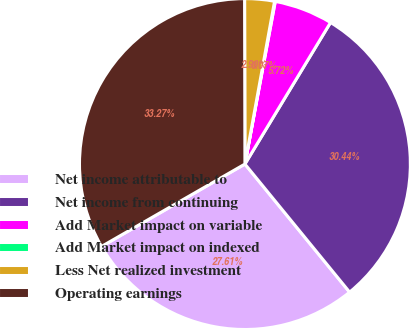Convert chart. <chart><loc_0><loc_0><loc_500><loc_500><pie_chart><fcel>Net income attributable to<fcel>Net income from continuing<fcel>Add Market impact on variable<fcel>Add Market impact on indexed<fcel>Less Net realized investment<fcel>Operating earnings<nl><fcel>27.61%<fcel>30.44%<fcel>5.72%<fcel>0.07%<fcel>2.9%<fcel>33.27%<nl></chart> 